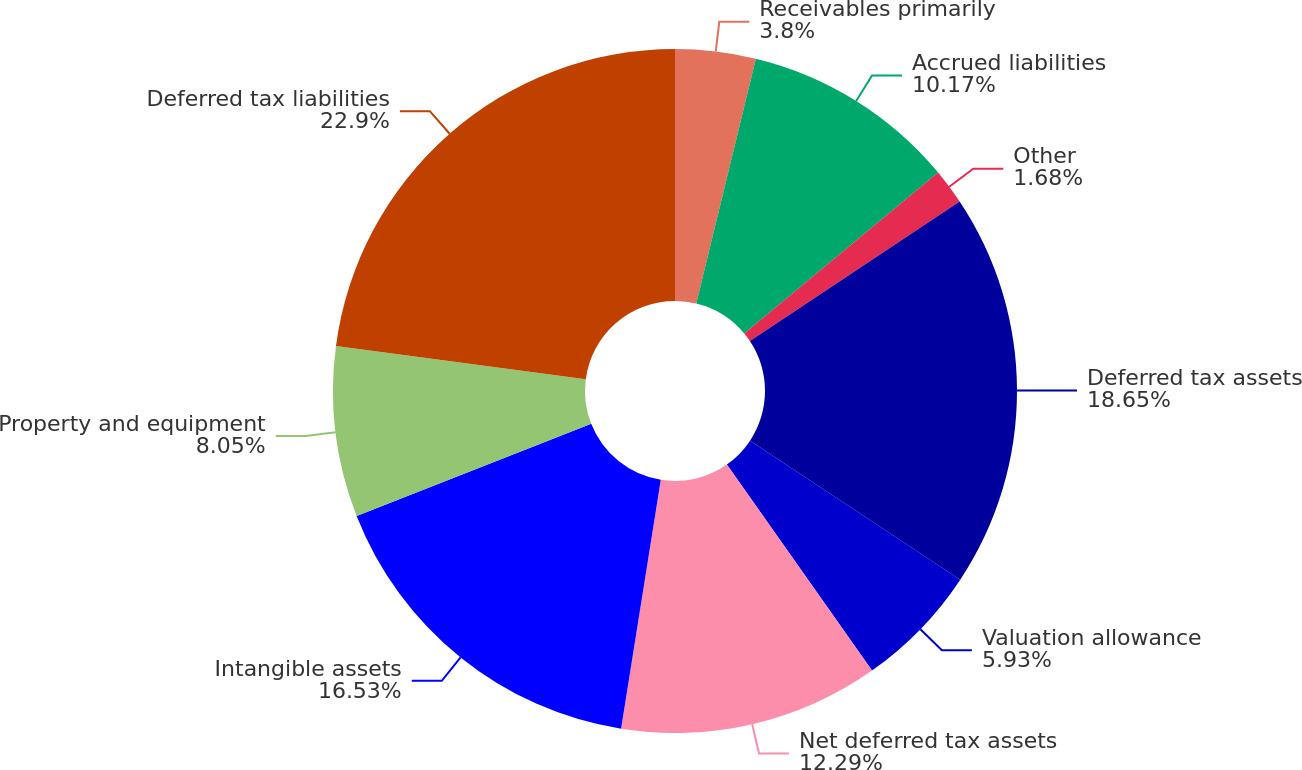Convert chart. <chart><loc_0><loc_0><loc_500><loc_500><pie_chart><fcel>Receivables primarily<fcel>Accrued liabilities<fcel>Other<fcel>Deferred tax assets<fcel>Valuation allowance<fcel>Net deferred tax assets<fcel>Intangible assets<fcel>Property and equipment<fcel>Deferred tax liabilities<nl><fcel>3.8%<fcel>10.17%<fcel>1.68%<fcel>18.65%<fcel>5.93%<fcel>12.29%<fcel>16.53%<fcel>8.05%<fcel>22.9%<nl></chart> 